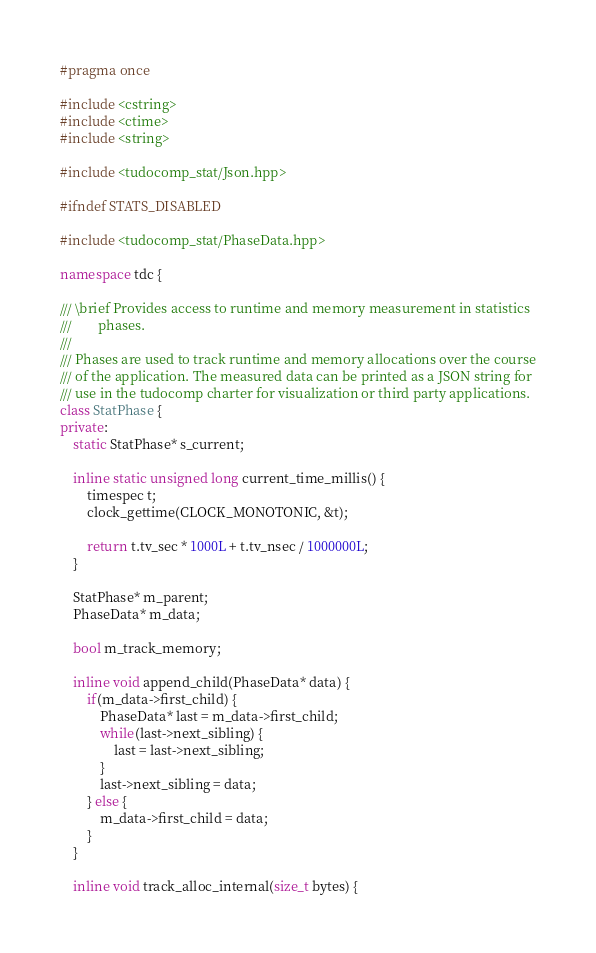Convert code to text. <code><loc_0><loc_0><loc_500><loc_500><_C++_>#pragma once

#include <cstring>
#include <ctime>
#include <string>

#include <tudocomp_stat/Json.hpp>

#ifndef STATS_DISABLED

#include <tudocomp_stat/PhaseData.hpp>

namespace tdc {

/// \brief Provides access to runtime and memory measurement in statistics
///        phases.
///
/// Phases are used to track runtime and memory allocations over the course
/// of the application. The measured data can be printed as a JSON string for
/// use in the tudocomp charter for visualization or third party applications.
class StatPhase {
private:
    static StatPhase* s_current;

    inline static unsigned long current_time_millis() {
        timespec t;
        clock_gettime(CLOCK_MONOTONIC, &t);

        return t.tv_sec * 1000L + t.tv_nsec / 1000000L;
    }

    StatPhase* m_parent;
    PhaseData* m_data;

    bool m_track_memory;

    inline void append_child(PhaseData* data) {
        if(m_data->first_child) {
            PhaseData* last = m_data->first_child;
            while(last->next_sibling) {
                last = last->next_sibling;
            }
            last->next_sibling = data;
        } else {
            m_data->first_child = data;
        }
    }

    inline void track_alloc_internal(size_t bytes) {</code> 